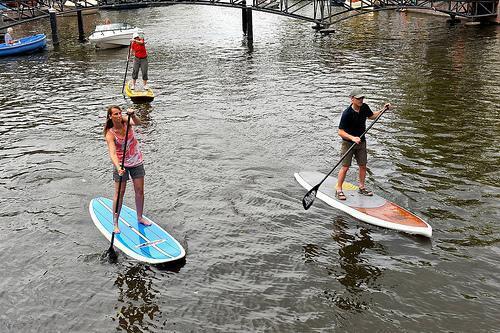How many people are in boats?
Give a very brief answer. 2. How many people are wearing black shirts?
Give a very brief answer. 1. How many people are paddle boarding in this picture?
Give a very brief answer. 3. 